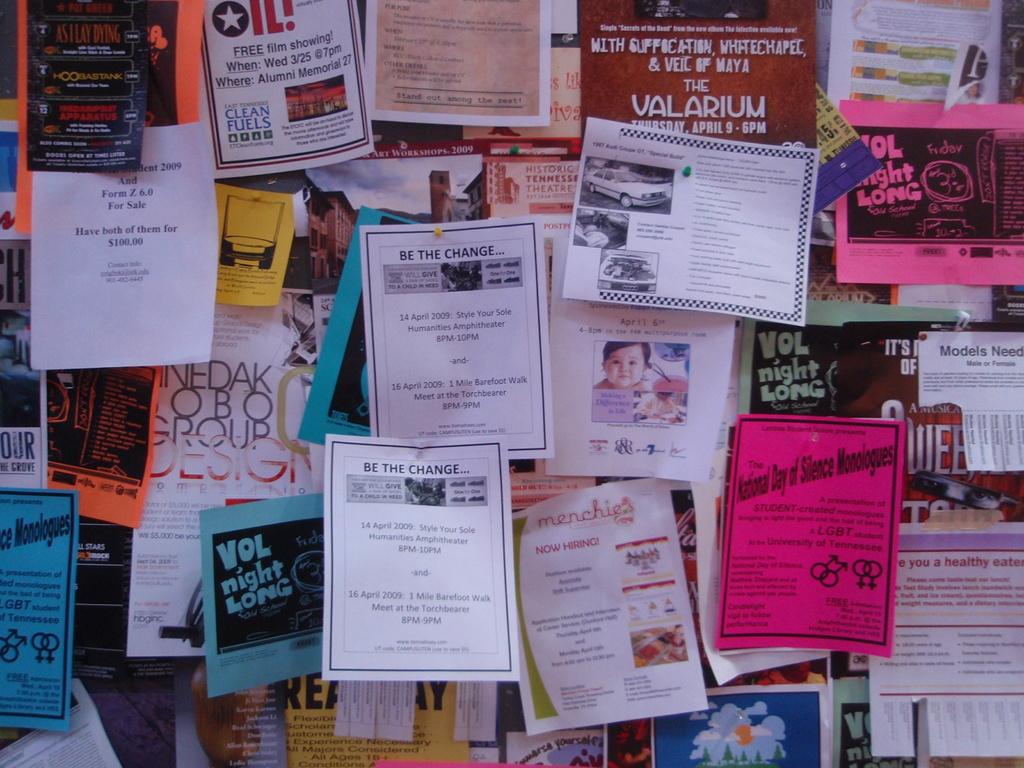What is the title on the white piece of paper that there are two of?
Your answer should be compact. Be the change. What is the title of the  sky blue paper?
Your answer should be compact. Vol night long. 